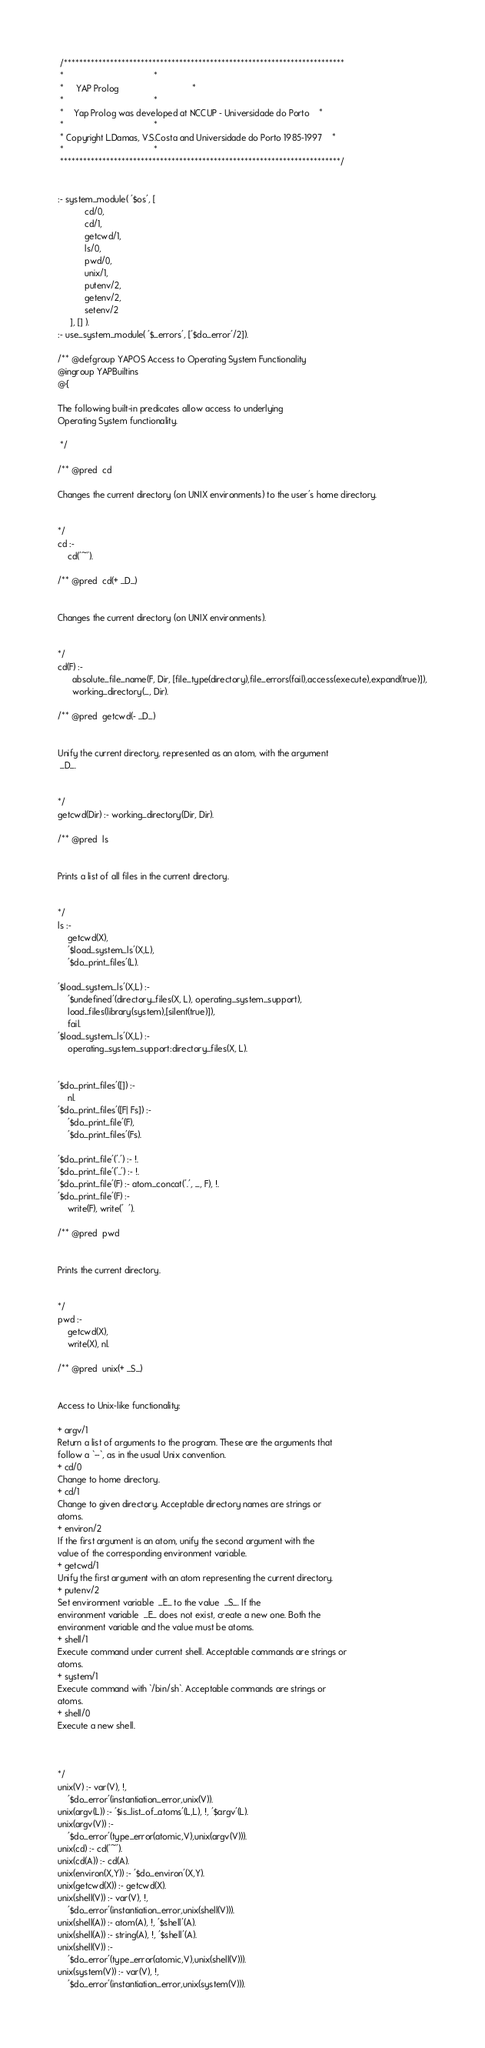<code> <loc_0><loc_0><loc_500><loc_500><_Prolog_> /*************************************************************************
 *									 *
 *	 YAP Prolog 							 *
 *									 *
 *	Yap Prolog was developed at NCCUP - Universidade do Porto	 *
 *									 *
 * Copyright L.Damas, V.S.Costa and Universidade do Porto 1985-1997	 *
 *									 *
 *************************************************************************/


:- system_module( '$os', [ 
	       cd/0,
	       cd/1,
	       getcwd/1,
	       ls/0,
	       pwd/0,
	       unix/1,
	       putenv/2,
	       getenv/2,
	       setenv/2
	 ], [] ).
:- use_system_module( '$_errors', ['$do_error'/2]).

/** @defgroup YAPOS Access to Operating System Functionality
@ingroup YAPBuiltins
@{

The following built-in predicates allow access to underlying
Operating System functionality.

 */

/** @pred  cd

Changes the current directory (on UNIX environments) to the user's home directory.

 
*/
cd :-
	cd('~').

/** @pred  cd(+ _D_) 


Changes the current directory (on UNIX environments).

 
*/
cd(F) :-
      absolute_file_name(F, Dir, [file_type(directory),file_errors(fail),access(execute),expand(true)]),
      working_directory(_, Dir).

/** @pred  getcwd(- _D_) 


Unify the current directory, represented as an atom, with the argument
 _D_.

 
*/
getcwd(Dir) :- working_directory(Dir, Dir).

/** @pred  ls 


Prints a list of all files in the current directory.

 
*/
ls :-
	getcwd(X),
	'$load_system_ls'(X,L),
	'$do_print_files'(L).

'$load_system_ls'(X,L) :-
	'$undefined'(directory_files(X, L), operating_system_support),
	load_files(library(system),[silent(true)]),
	fail.
'$load_system_ls'(X,L) :-
	operating_system_support:directory_files(X, L).
	

'$do_print_files'([]) :-
	nl.
'$do_print_files'([F| Fs]) :-
	'$do_print_file'(F),
	'$do_print_files'(Fs).

'$do_print_file'('.') :- !.
'$do_print_file'('..') :- !.
'$do_print_file'(F) :- atom_concat('.', _, F), !.
'$do_print_file'(F) :-
	write(F), write('  ').

/** @pred  pwd 


Prints the current directory.

 
*/
pwd :-
	getcwd(X),
	write(X), nl.

/** @pred  unix(+ _S_) 


Access to Unix-like functionality:

+ argv/1
Return a list of arguments to the program. These are the arguments that
follow a `--`, as in the usual Unix convention.
+ cd/0
Change to home directory.
+ cd/1
Change to given directory. Acceptable directory names are strings or
atoms.
+ environ/2
If the first argument is an atom, unify the second argument with the
value of the corresponding environment variable.
+ getcwd/1
Unify the first argument with an atom representing the current directory.
+ putenv/2
Set environment variable  _E_ to the value  _S_. If the
environment variable  _E_ does not exist, create a new one. Both the
environment variable and the value must be atoms.
+ shell/1
Execute command under current shell. Acceptable commands are strings or
atoms.
+ system/1
Execute command with `/bin/sh`. Acceptable commands are strings or
atoms.
+ shell/0
Execute a new shell.


 
*/
unix(V) :- var(V), !,
	'$do_error'(instantiation_error,unix(V)).
unix(argv(L)) :- '$is_list_of_atoms'(L,L), !, '$argv'(L).
unix(argv(V)) :-
	'$do_error'(type_error(atomic,V),unix(argv(V))).
unix(cd) :- cd('~').
unix(cd(A)) :- cd(A).
unix(environ(X,Y)) :- '$do_environ'(X,Y).
unix(getcwd(X)) :- getcwd(X).
unix(shell(V)) :- var(V), !,
	'$do_error'(instantiation_error,unix(shell(V))).
unix(shell(A)) :- atom(A), !, '$shell'(A).
unix(shell(A)) :- string(A), !, '$shell'(A).
unix(shell(V)) :-
	'$do_error'(type_error(atomic,V),unix(shell(V))).
unix(system(V)) :- var(V), !,
	'$do_error'(instantiation_error,unix(system(V))).</code> 